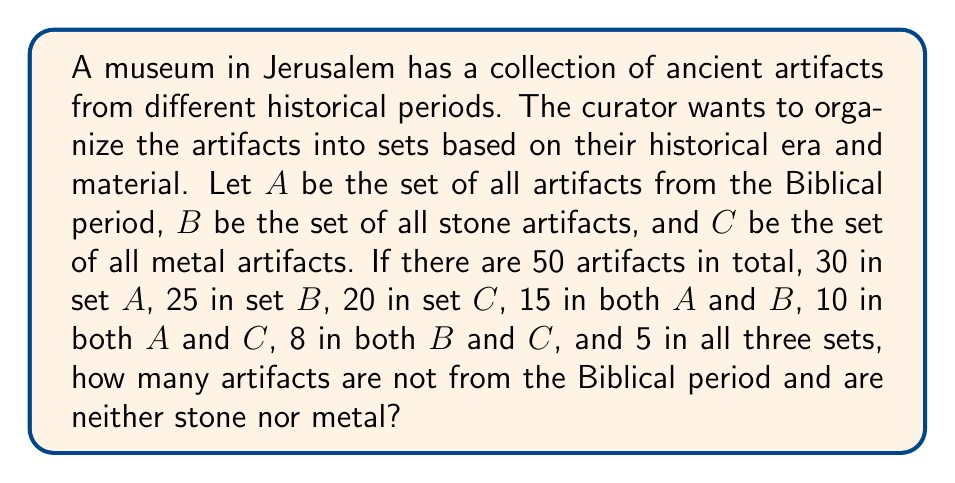Give your solution to this math problem. To solve this problem, we'll use set theory concepts, particularly the principle of inclusion-exclusion.

Let's define the universal set U as all artifacts in the museum (50 in total).

Step 1: Calculate |A ∪ B ∪ C|
Using the inclusion-exclusion principle:
$$ |A ∪ B ∪ C| = |A| + |B| + |C| - |A ∩ B| - |A ∩ C| - |B ∩ C| + |A ∩ B ∩ C| $$
$$ |A ∪ B ∪ C| = 30 + 25 + 20 - 15 - 10 - 8 + 5 = 47 $$

Step 2: Calculate the number of artifacts not in A ∪ B ∪ C
$$ |U - (A ∪ B ∪ C)| = |U| - |A ∪ B ∪ C| = 50 - 47 = 3 $$

Therefore, there are 3 artifacts that are not from the Biblical period and are neither stone nor metal.
Answer: 3 artifacts 